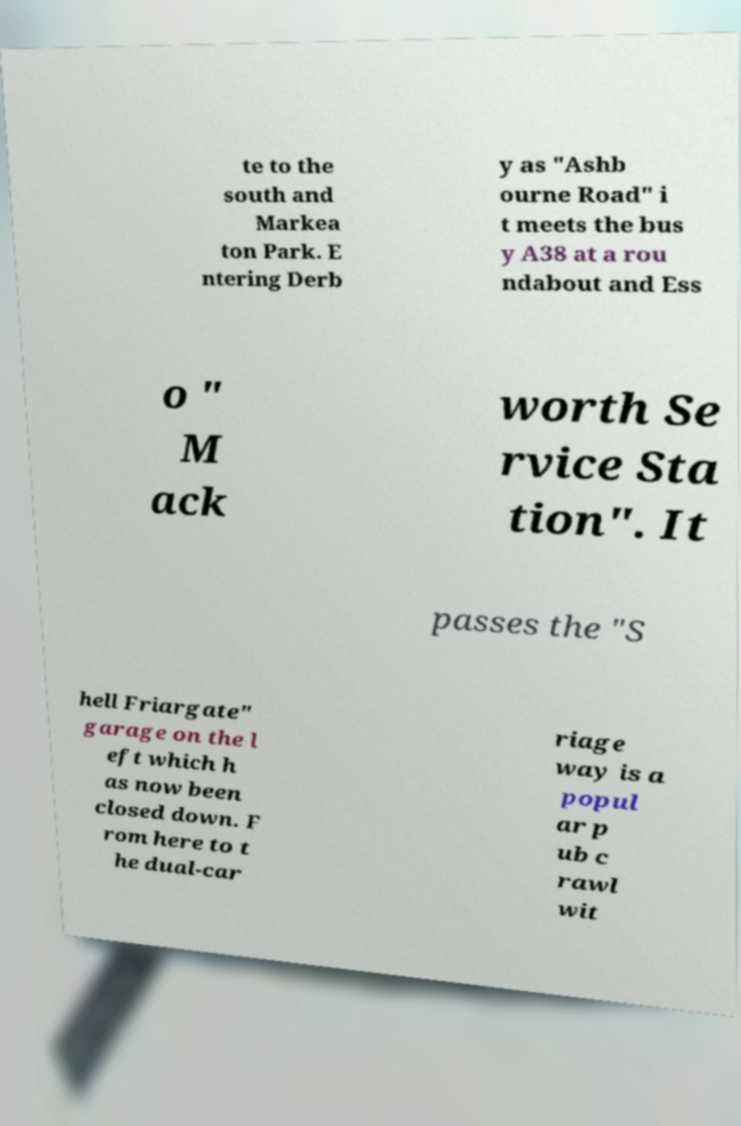Could you assist in decoding the text presented in this image and type it out clearly? te to the south and Markea ton Park. E ntering Derb y as "Ashb ourne Road" i t meets the bus y A38 at a rou ndabout and Ess o " M ack worth Se rvice Sta tion". It passes the "S hell Friargate" garage on the l eft which h as now been closed down. F rom here to t he dual-car riage way is a popul ar p ub c rawl wit 